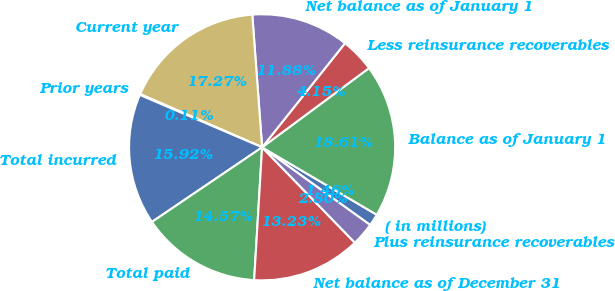<chart> <loc_0><loc_0><loc_500><loc_500><pie_chart><fcel>( in millions)<fcel>Balance as of January 1<fcel>Less reinsurance recoverables<fcel>Net balance as of January 1<fcel>Current year<fcel>Prior years<fcel>Total incurred<fcel>Total paid<fcel>Net balance as of December 31<fcel>Plus reinsurance recoverables<nl><fcel>1.46%<fcel>18.61%<fcel>4.15%<fcel>11.88%<fcel>17.27%<fcel>0.11%<fcel>15.92%<fcel>14.57%<fcel>13.23%<fcel>2.8%<nl></chart> 